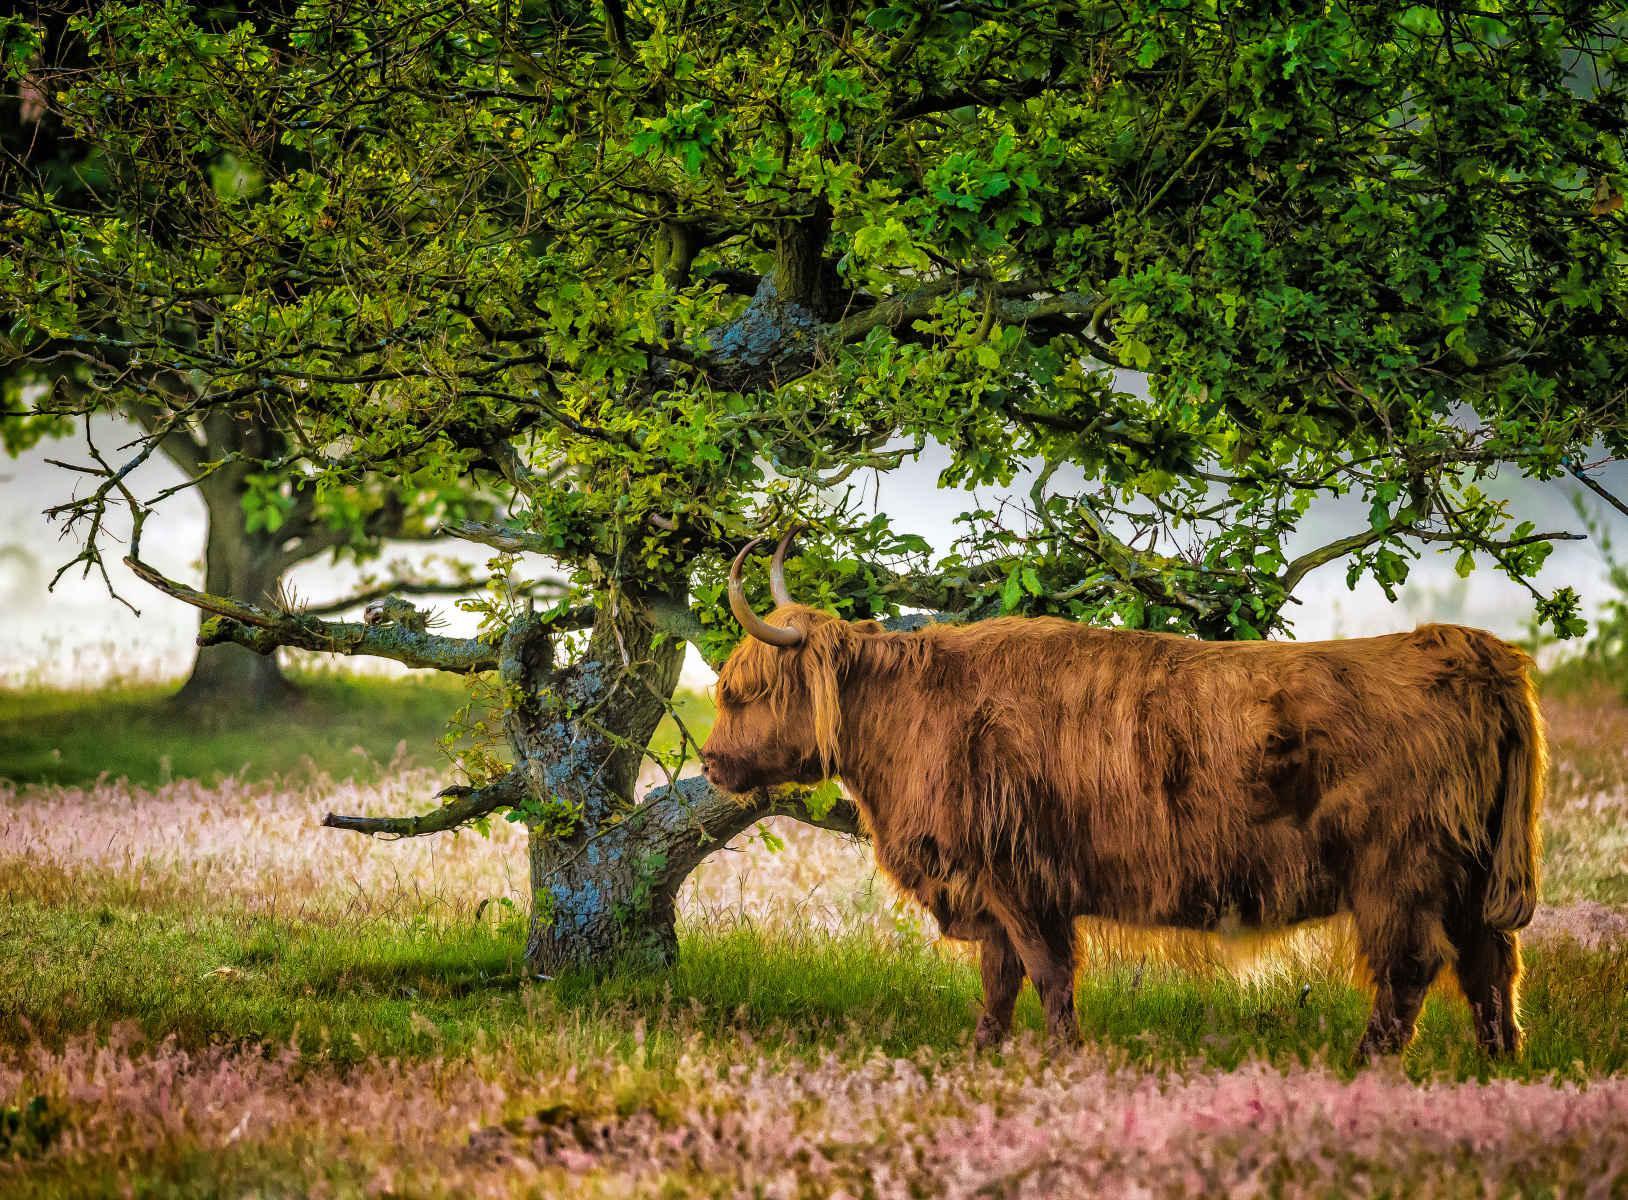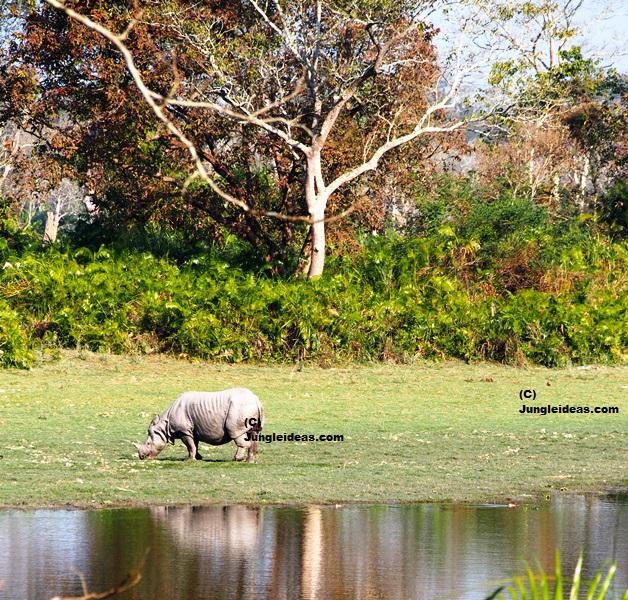The first image is the image on the left, the second image is the image on the right. Assess this claim about the two images: "Each image contains one hooved animal standing in profile, each animal is an adult cow with horns, and the animals on the left and right have their bodies turned in the same direction.". Correct or not? Answer yes or no. No. The first image is the image on the left, the second image is the image on the right. Given the left and right images, does the statement "One large animal is eating grass near a pond." hold true? Answer yes or no. Yes. 